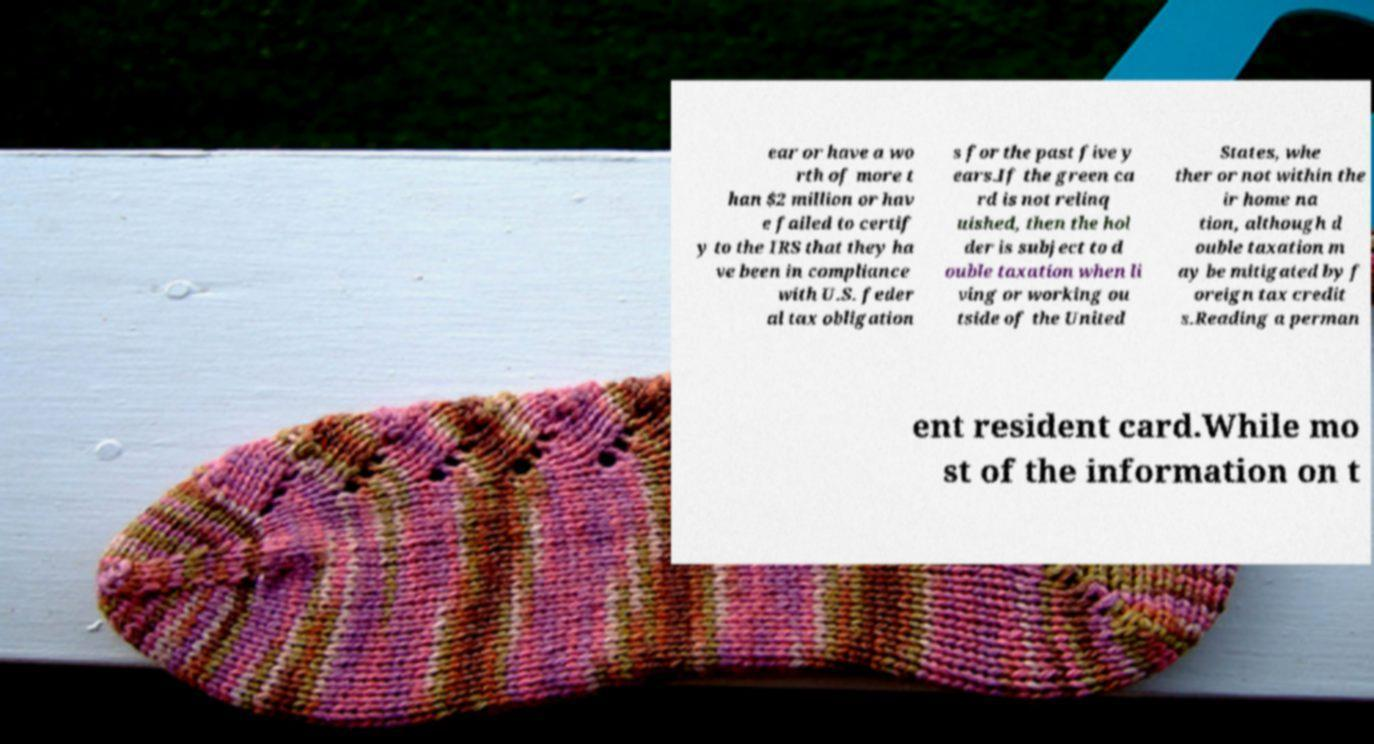Can you read and provide the text displayed in the image?This photo seems to have some interesting text. Can you extract and type it out for me? ear or have a wo rth of more t han $2 million or hav e failed to certif y to the IRS that they ha ve been in compliance with U.S. feder al tax obligation s for the past five y ears.If the green ca rd is not relinq uished, then the hol der is subject to d ouble taxation when li ving or working ou tside of the United States, whe ther or not within the ir home na tion, although d ouble taxation m ay be mitigated by f oreign tax credit s.Reading a perman ent resident card.While mo st of the information on t 